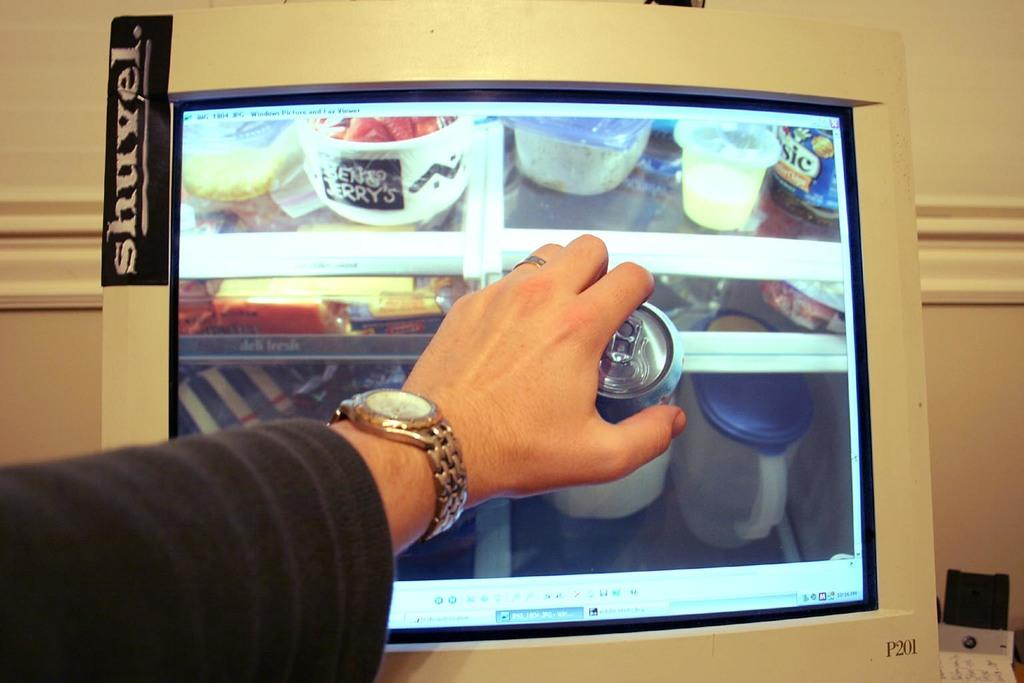What part of a person can be seen in the image? There is a person's hand in the image. What electronic device is present in the image? There is a monitor in the image. What else can be seen in the image besides the hand and monitor? There are objects in the image. What type of background is visible in the image? There is a wall in the image. What type of disease can be seen on the monitor in the image? There is no disease visible on the monitor in the image. How many eggs are present on the wall in the image? There are no eggs present on the wall in the image. 